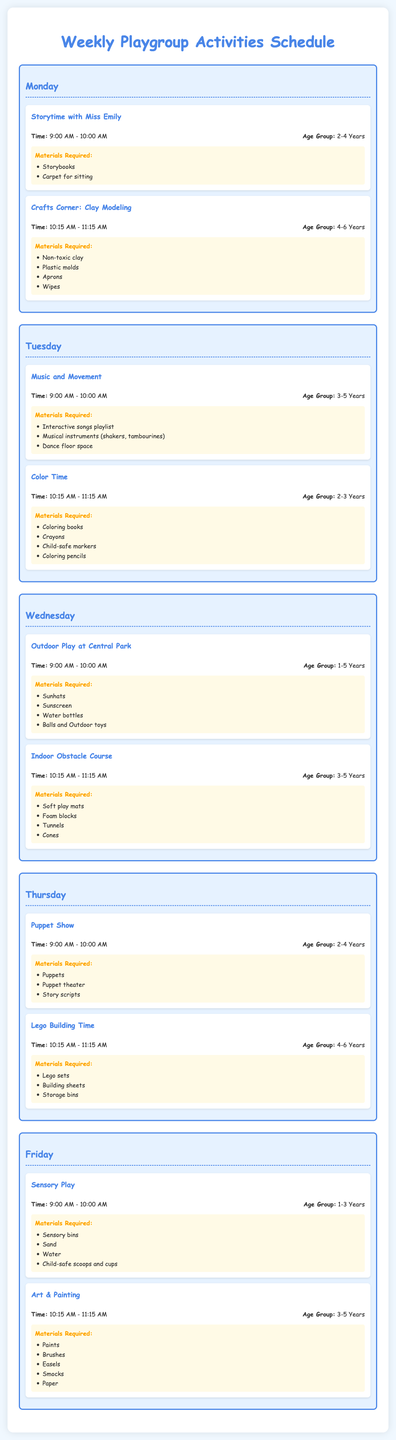What activity is scheduled on Monday at 9:00 AM? The activity scheduled on Monday at 9:00 AM is Storytime with Miss Emily.
Answer: Storytime with Miss Emily What materials are required for Crafts Corner: Clay Modeling? The materials required for Crafts Corner: Clay Modeling include non-toxic clay, plastic molds, aprons, and wipes.
Answer: Non-toxic clay, plastic molds, aprons, wipes What age group is targeted for Music and Movement? The age group targeted for Music and Movement is 3-5 years.
Answer: 3-5 Years What is the timing for Color Time? The timing for Color Time is 10:15 AM - 11:15 AM.
Answer: 10:15 AM - 11:15 AM On which day is the Puppet Show scheduled? The Puppet Show is scheduled on Thursday.
Answer: Thursday Which activity includes outdoor play? The activity that includes outdoor play is Outdoor Play at Central Park.
Answer: Outdoor Play at Central Park What type of play is scheduled for Friday at 9:00 AM? The type of play scheduled for Friday at 9:00 AM is Sensory Play.
Answer: Sensory Play How long is each activity typically scheduled for? Each activity is typically scheduled for 1 hour.
Answer: 1 hour What materials are used for Art & Painting? The materials used for Art & Painting include paints, brushes, easels, smocks, and paper.
Answer: Paints, brushes, easels, smocks, paper 